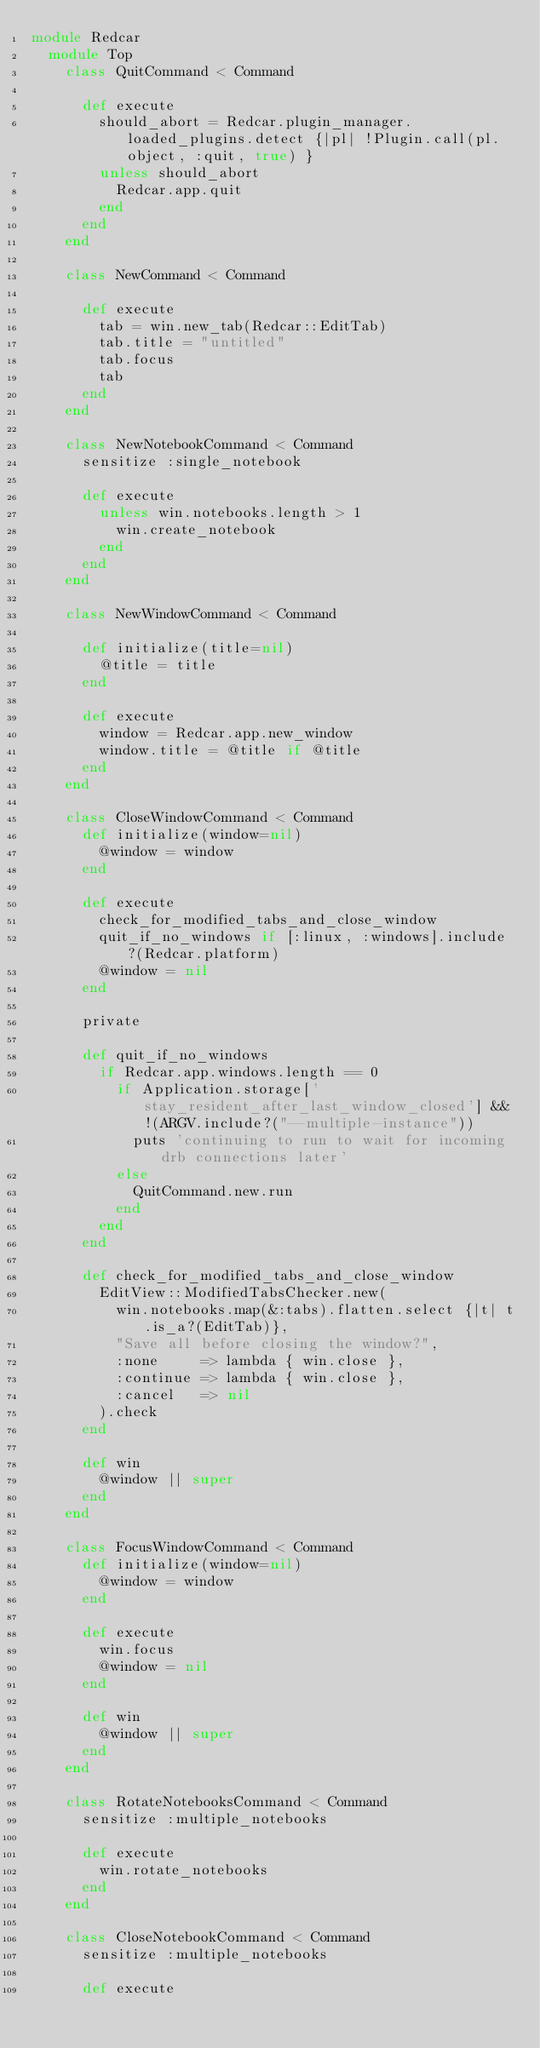<code> <loc_0><loc_0><loc_500><loc_500><_Ruby_>module Redcar
  module Top
    class QuitCommand < Command
      
      def execute
        should_abort = Redcar.plugin_manager.loaded_plugins.detect {|pl| !Plugin.call(pl.object, :quit, true) }
        unless should_abort
          Redcar.app.quit
        end
      end
    end
    
    class NewCommand < Command
      
      def execute
        tab = win.new_tab(Redcar::EditTab)
        tab.title = "untitled"
        tab.focus
        tab
      end
    end
    
    class NewNotebookCommand < Command
      sensitize :single_notebook
      
      def execute
        unless win.notebooks.length > 1
          win.create_notebook
        end
      end
    end
    
    class NewWindowCommand < Command
      
      def initialize(title=nil)
        @title = title
      end
      
      def execute
        window = Redcar.app.new_window
        window.title = @title if @title
      end
    end
    
    class CloseWindowCommand < Command
      def initialize(window=nil)
        @window = window
      end
    
      def execute
        check_for_modified_tabs_and_close_window
        quit_if_no_windows if [:linux, :windows].include?(Redcar.platform)
        @window = nil
      end
      
      private
      
      def quit_if_no_windows
        if Redcar.app.windows.length == 0
          if Application.storage['stay_resident_after_last_window_closed'] && !(ARGV.include?("--multiple-instance"))
            puts 'continuing to run to wait for incoming drb connections later'
          else
            QuitCommand.new.run
          end
        end
      end
      
      def check_for_modified_tabs_and_close_window
        EditView::ModifiedTabsChecker.new(
          win.notebooks.map(&:tabs).flatten.select {|t| t.is_a?(EditTab)}, 
          "Save all before closing the window?",
          :none     => lambda { win.close },
          :continue => lambda { win.close },
          :cancel   => nil
        ).check
      end
      
      def win
        @window || super
      end
    end
    
    class FocusWindowCommand < Command
      def initialize(window=nil)
        @window = window
      end
    
      def execute
        win.focus
        @window = nil
      end
      
      def win
        @window || super
      end
    end
    
    class RotateNotebooksCommand < Command
      sensitize :multiple_notebooks
          
      def execute
        win.rotate_notebooks
      end
    end
    
    class CloseNotebookCommand < Command
      sensitize :multiple_notebooks
          
      def execute</code> 